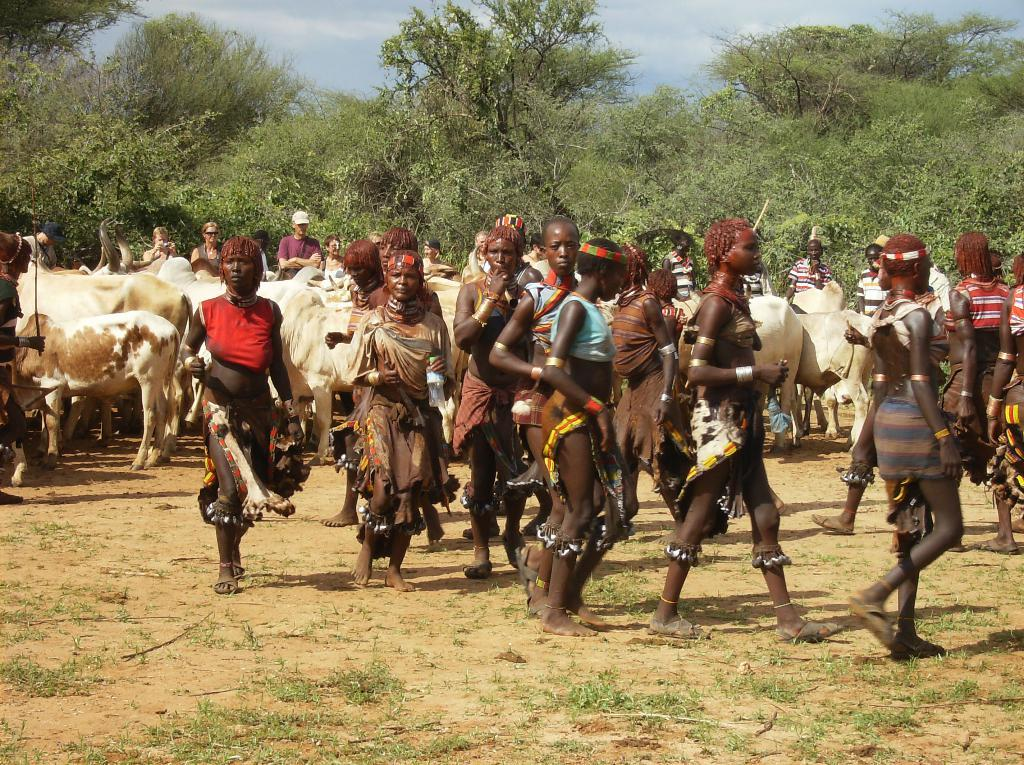What are the people in the image doing? There is a group of people walking in the image. What animals are present in the image? There is a herd of cattle in the image. What type of vegetation can be seen in the image? There are trees with branches and leaves in the image. Are there any people standing in the image? Yes, there are people standing in the image. What type of thrill can be seen on the faces of the cattle in the image? There is no indication of any thrill on the faces of the cattle in the image, as they are animals and do not have facial expressions like humans. 